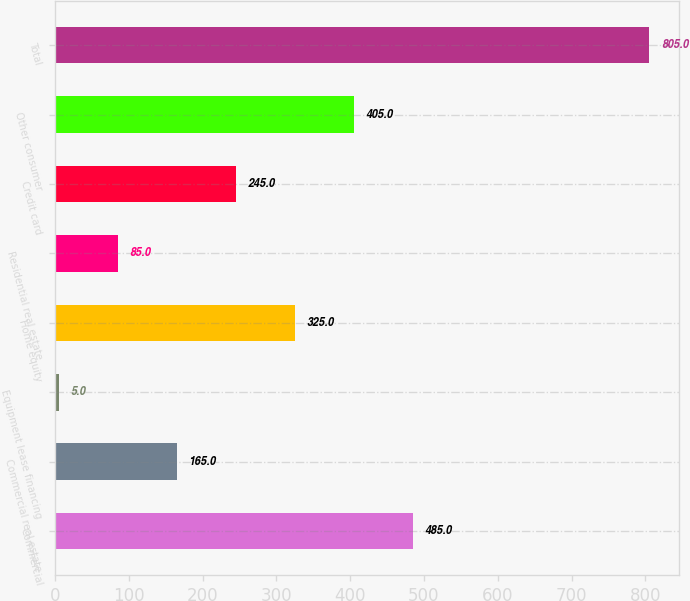Convert chart to OTSL. <chart><loc_0><loc_0><loc_500><loc_500><bar_chart><fcel>Commercial<fcel>Commercial real estate<fcel>Equipment lease financing<fcel>Home equity<fcel>Residential real estate<fcel>Credit card<fcel>Other consumer<fcel>Total<nl><fcel>485<fcel>165<fcel>5<fcel>325<fcel>85<fcel>245<fcel>405<fcel>805<nl></chart> 